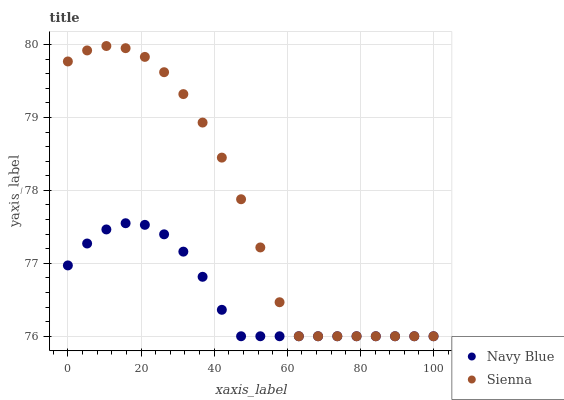Does Navy Blue have the minimum area under the curve?
Answer yes or no. Yes. Does Sienna have the maximum area under the curve?
Answer yes or no. Yes. Does Navy Blue have the maximum area under the curve?
Answer yes or no. No. Is Navy Blue the smoothest?
Answer yes or no. Yes. Is Sienna the roughest?
Answer yes or no. Yes. Is Navy Blue the roughest?
Answer yes or no. No. Does Sienna have the lowest value?
Answer yes or no. Yes. Does Sienna have the highest value?
Answer yes or no. Yes. Does Navy Blue have the highest value?
Answer yes or no. No. Does Sienna intersect Navy Blue?
Answer yes or no. Yes. Is Sienna less than Navy Blue?
Answer yes or no. No. Is Sienna greater than Navy Blue?
Answer yes or no. No. 